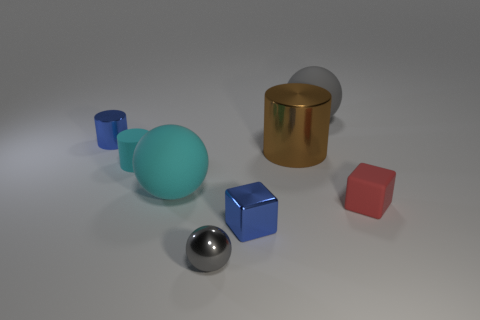What number of rubber things are big yellow cylinders or big brown objects?
Provide a short and direct response. 0. Does the gray object that is in front of the tiny red cube have the same shape as the gray thing that is behind the small blue cube?
Give a very brief answer. Yes. Are there any tiny cyan objects that have the same material as the cyan cylinder?
Keep it short and to the point. No. What is the color of the small ball?
Offer a very short reply. Gray. How big is the cyan object in front of the small cyan rubber cylinder?
Provide a short and direct response. Large. How many rubber things have the same color as the small sphere?
Offer a terse response. 1. There is a big object that is in front of the tiny rubber cylinder; is there a large cyan thing behind it?
Make the answer very short. No. Is the color of the block on the left side of the red matte object the same as the tiny rubber thing that is to the right of the gray matte thing?
Give a very brief answer. No. There is a sphere that is the same size as the cyan rubber cylinder; what color is it?
Your answer should be very brief. Gray. Are there an equal number of tiny spheres in front of the small gray shiny object and small blue cylinders that are in front of the small rubber block?
Offer a very short reply. Yes. 